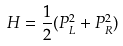<formula> <loc_0><loc_0><loc_500><loc_500>H = \frac { 1 } { 2 } ( P _ { L } ^ { 2 } + P _ { R } ^ { 2 } )</formula> 